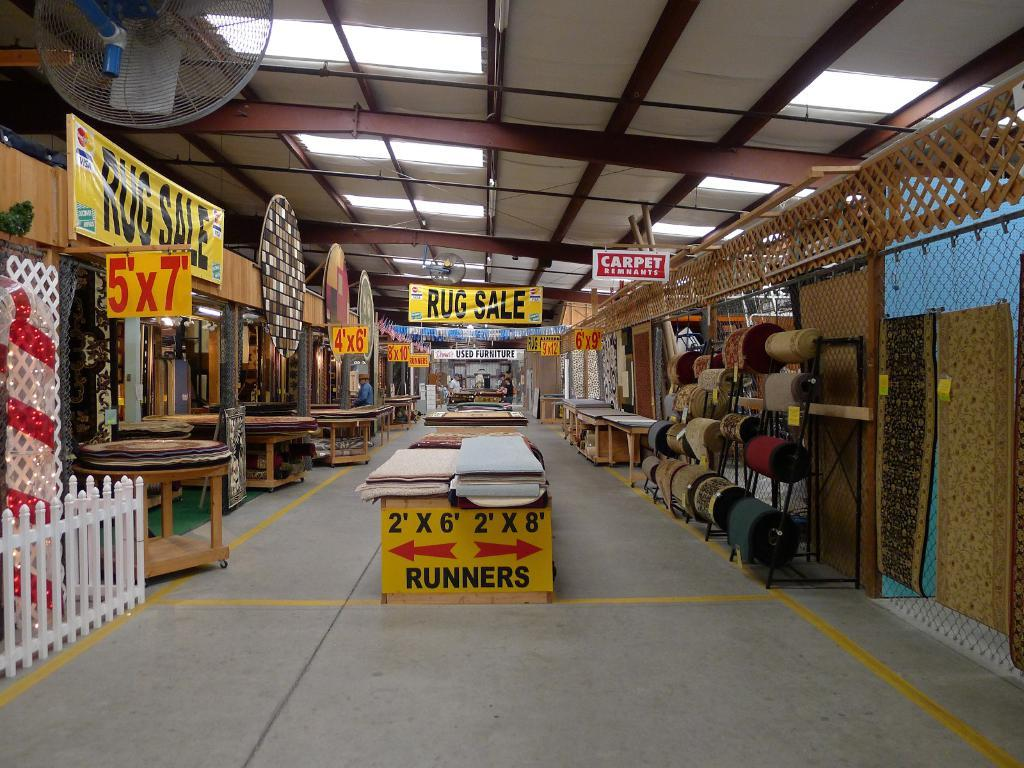<image>
Offer a succinct explanation of the picture presented. In a large room there is a banner that says "Rug Sale" hanging from the ceiling. 